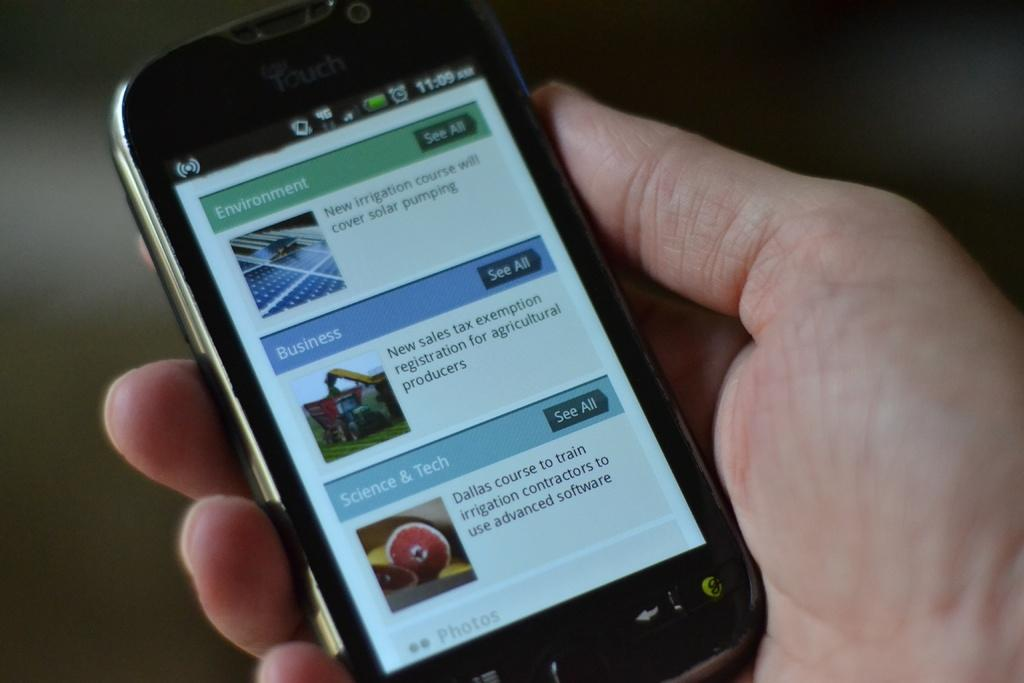<image>
Provide a brief description of the given image. a hand holding a phone whose screen is displaying several types of articles like business and entertainment. 